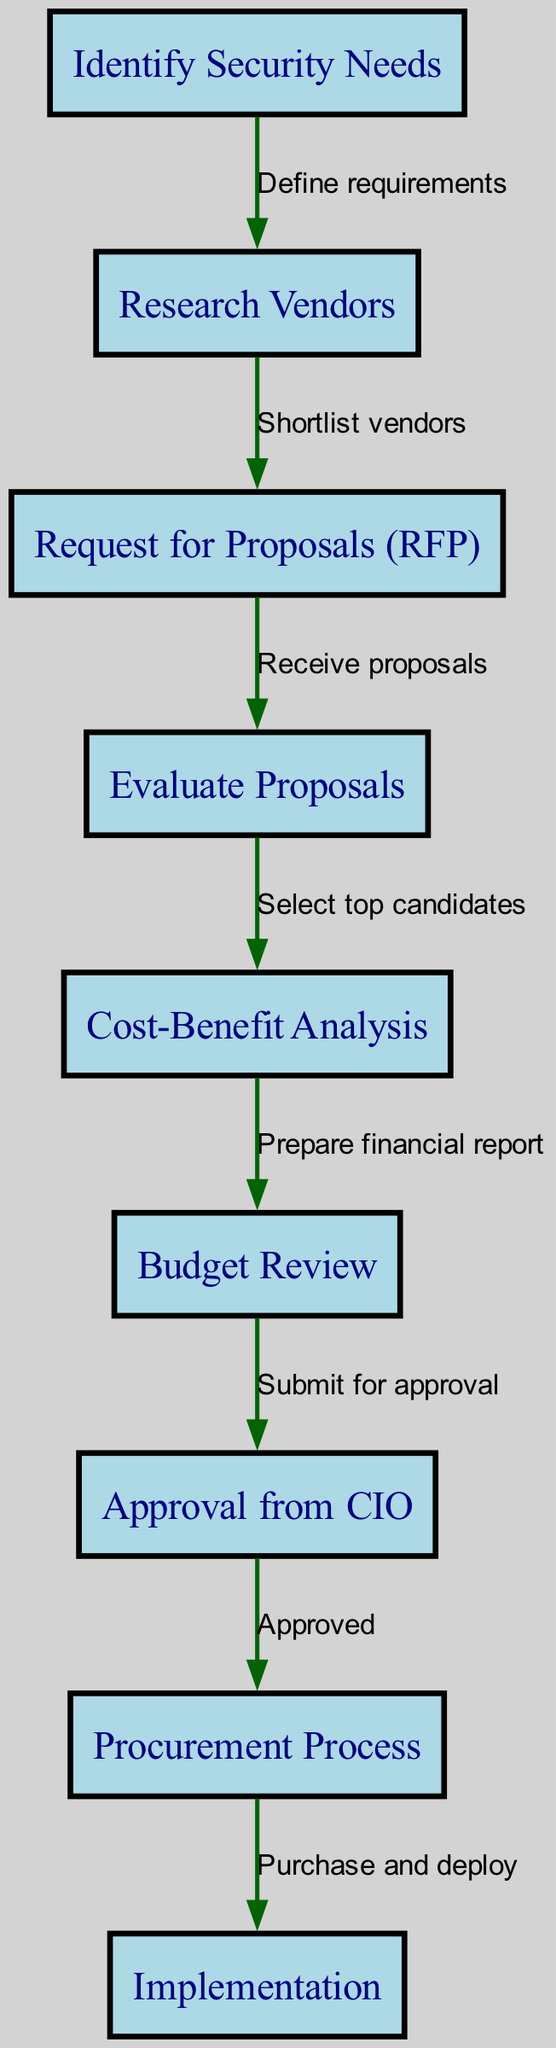What is the first step in the procurement process? The first step is "Identify Security Needs." It is represented as the first node in the flowchart indicating the starting point of the process.
Answer: Identify Security Needs How many nodes are there in the diagram? By counting all distinct steps represented as nodes in the flowchart, we find there are nine nodes in total.
Answer: 9 What follows the "Cost-Benefit Analysis" step? The next step after "Cost-Benefit Analysis" is "Budget Review," as indicated by the directed edge connecting them in the flowchart.
Answer: Budget Review Which step requires approval from the CIO? The step that requires approval from the CIO is labeled "Approval from CIO," which is specifically represented as node seven in the diagram.
Answer: Approval from CIO What is the final step in the procurement and approval process? The final step in the process is "Implementation," which is the last node that follows after "Procurement Process."
Answer: Implementation How do we move from "Research Vendors" to "Request for Proposals"? We move from "Research Vendors" to "Request for Proposals" through the directed edge labeled "Shortlist vendors," which signifies the action taken to transition between these two steps.
Answer: Shortlist vendors What is required before the "Implementation" step? Before the "Implementation" step, the "Procurement Process" must be completed, which indicates the need for prior actions to be followed for effective final deployment.
Answer: Procurement Process How many edges connect the nodes in the diagram? By counting the directional relationships or actions represented by the edges, we find that there are eight edges in total.
Answer: 8 Which step leads to the "Purchase and deploy" action? The step that leads to the "Purchase and deploy" action is "Procurement Process," as shown in the flowchart.
Answer: Procurement Process 